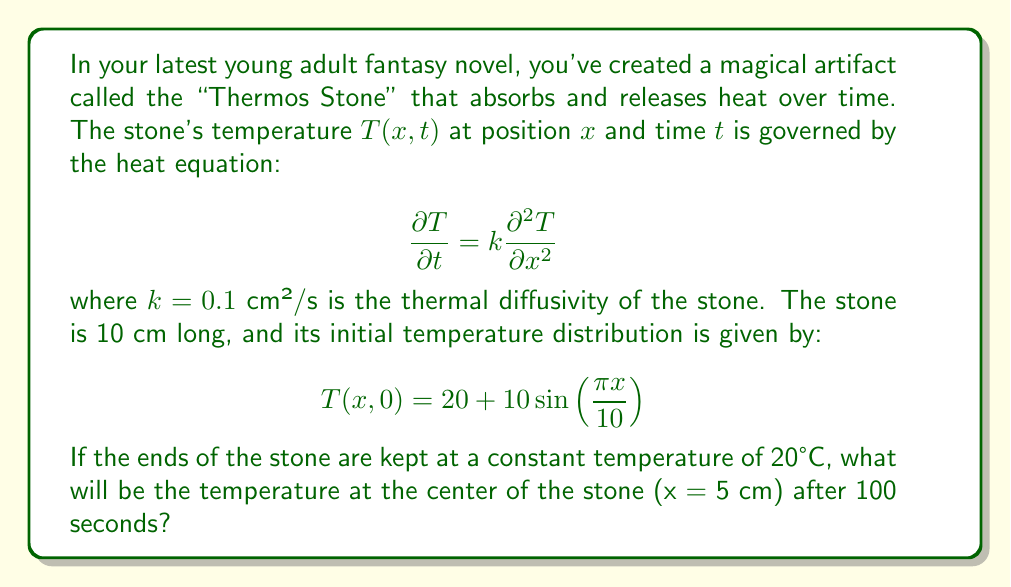Could you help me with this problem? To solve this problem, we need to use the separation of variables method for the heat equation with given boundary conditions. Let's follow these steps:

1) The general solution for the heat equation with these boundary conditions is:

   $$T(x,t) = 20 + \sum_{n=1}^{\infty} B_n \sin(\frac{n\pi x}{L})e^{-k(\frac{n\pi}{L})^2t}$$

   where $L = 10$ cm is the length of the stone.

2) We need to find $B_n$ using the initial condition:

   $$20 + 10\sin(\frac{\pi x}{10}) = 20 + \sum_{n=1}^{\infty} B_n \sin(\frac{n\pi x}{10})$$

3) Comparing the terms, we can see that $B_1 = 10$ and $B_n = 0$ for $n > 1$.

4) Therefore, our solution simplifies to:

   $$T(x,t) = 20 + 10\sin(\frac{\pi x}{10})e^{-k(\frac{\pi}{10})^2t}$$

5) Now, we need to evaluate this at $x = 5$ cm and $t = 100$ s:

   $$T(5,100) = 20 + 10\sin(\frac{\pi \cdot 5}{10})e^{-0.1(\frac{\pi}{10})^2 \cdot 100}$$

6) Simplify:
   $$T(5,100) = 20 + 10 \cdot 1 \cdot e^{-0.1(\frac{\pi^2}{100})}$$
   $$T(5,100) = 20 + 10e^{-0.1\pi^2/100}$$

7) Calculate the final value:
   $$T(5,100) \approx 20 + 10 \cdot 0.7046 \approx 27.05°C$$
Answer: 27.05°C 